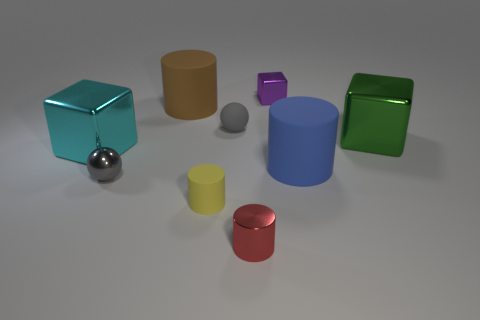There is a object that is the same color as the metallic sphere; what is it made of?
Keep it short and to the point. Rubber. How many other objects are there of the same color as the small metallic ball?
Your response must be concise. 1. How many things are objects that are in front of the cyan block or small green cylinders?
Offer a terse response. 4. How many things are either yellow rubber things or matte things behind the big blue rubber cylinder?
Provide a succinct answer. 3. What number of other metal cubes have the same size as the green block?
Ensure brevity in your answer.  1. Are there fewer big metallic objects that are to the left of the tiny yellow matte thing than big matte things to the right of the purple cube?
Provide a short and direct response. No. How many metallic things are either tiny purple objects or small gray blocks?
Keep it short and to the point. 1. The brown rubber object is what shape?
Provide a short and direct response. Cylinder. There is a green thing that is the same size as the brown thing; what is its material?
Give a very brief answer. Metal. What number of small objects are metallic cylinders or brown rubber cubes?
Provide a succinct answer. 1. 